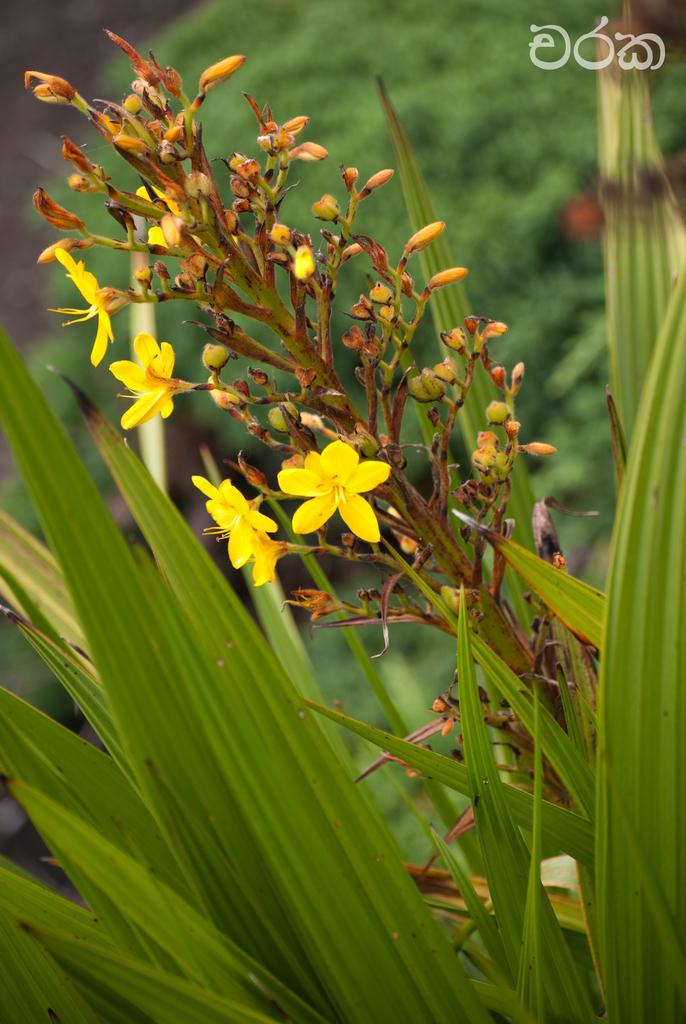What type of vegetation can be seen in the image? There are plants, flowers, and trees in the image. Can you describe the flowers in the image? The flowers in the image are colorful and appear to be in bloom. What is the difference between the plants and trees in the image? The plants are smaller and may be herbaceous, while the trees are larger and have woody stems. What type of teaching method is being used in the image? There is no teaching or educational context present in the image; it features plants, flowers, and trees. What type of poison or disease can be seen affecting the plants in the image? There is no indication of any poison or disease affecting the plants in the image; they appear healthy and vibrant. 